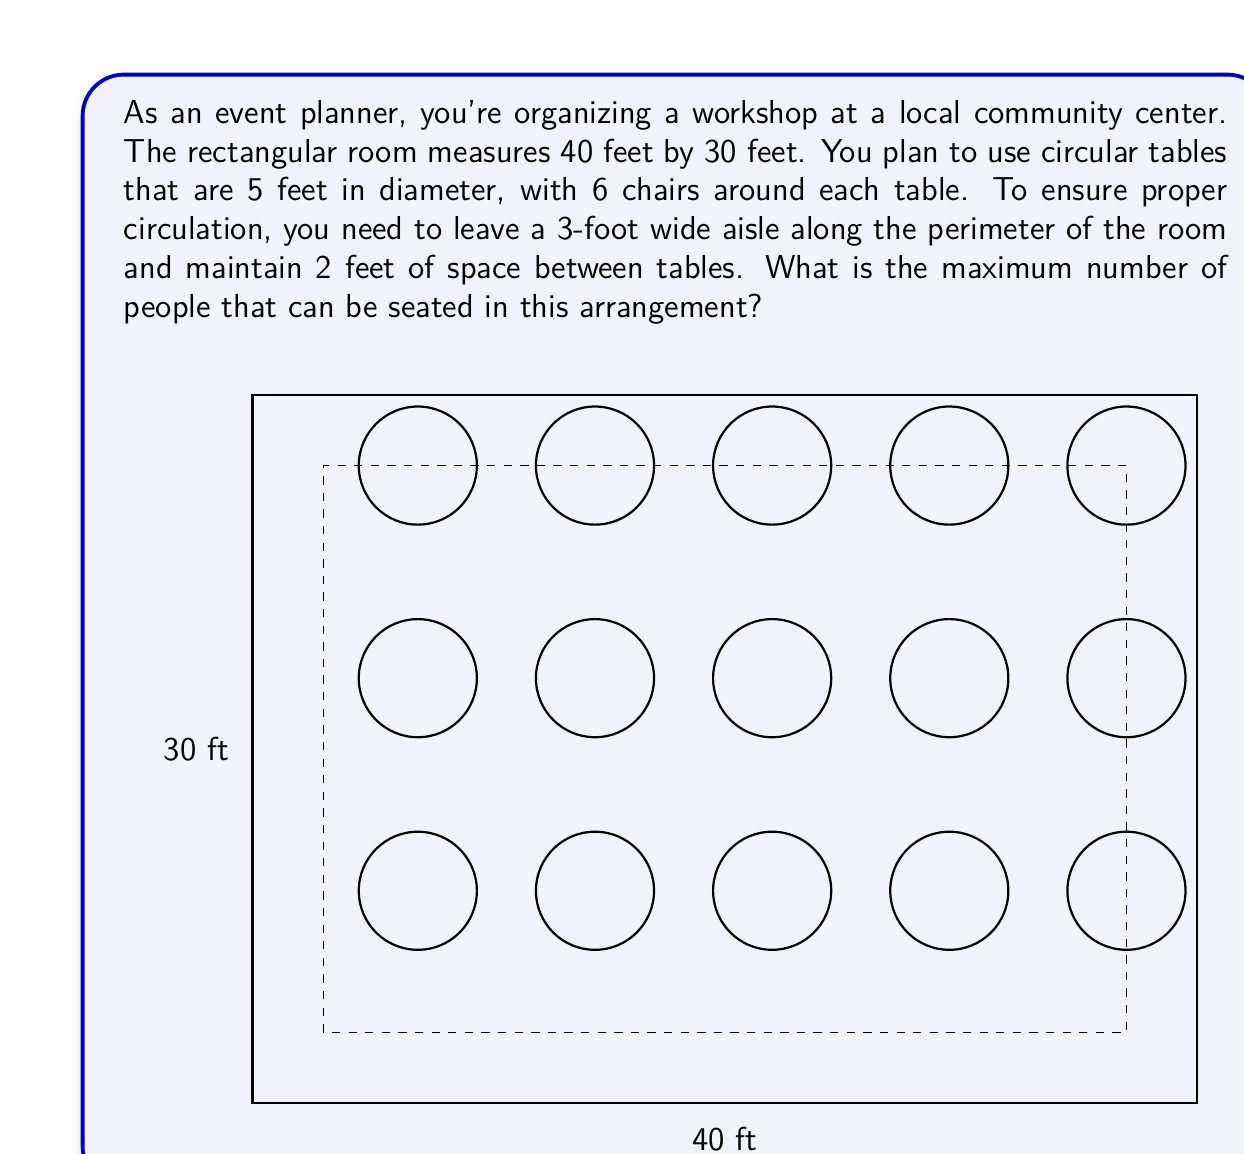Show me your answer to this math problem. Let's approach this problem step by step:

1) First, calculate the usable area of the room:
   - Room dimensions: 40 ft × 30 ft
   - Aisle width: 3 ft
   - Usable area: (40 - 2×3) × (30 - 2×3) = 34 ft × 24 ft

2) Determine the space needed for each table:
   - Table diameter: 5 ft
   - Space between tables: 2 ft
   - Total space per table: 5 + 2 = 7 ft in each direction

3) Calculate how many tables can fit in each direction:
   - In the length: $\lfloor \frac{34}{7} \rfloor = 4$ tables
   - In the width: $\lfloor \frac{24}{7} \rfloor = 3$ tables

4) Total number of tables:
   $4 \times 3 = 12$ tables

5) Since each table can seat 6 people, calculate the total seating capacity:
   $12 \times 6 = 72$ people

Therefore, the maximum number of people that can be seated is 72.

Note: The floor function $\lfloor x \rfloor$ is used to round down to the nearest integer, ensuring we don't exceed the room's dimensions.
Answer: 72 people 